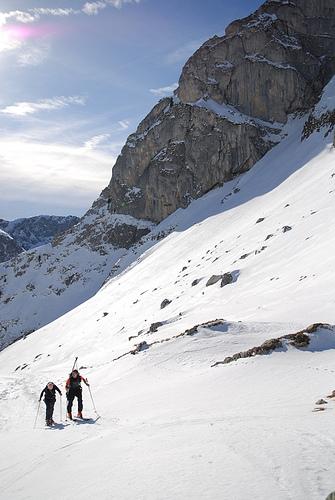Is it cold here?
Concise answer only. Yes. What are those people doing?
Be succinct. Skiing. Is this person skiing?
Concise answer only. Yes. Are they lost?
Concise answer only. No. Are there tracks in the snow?
Be succinct. Yes. Could they get a sunburn?
Quick response, please. Yes. 